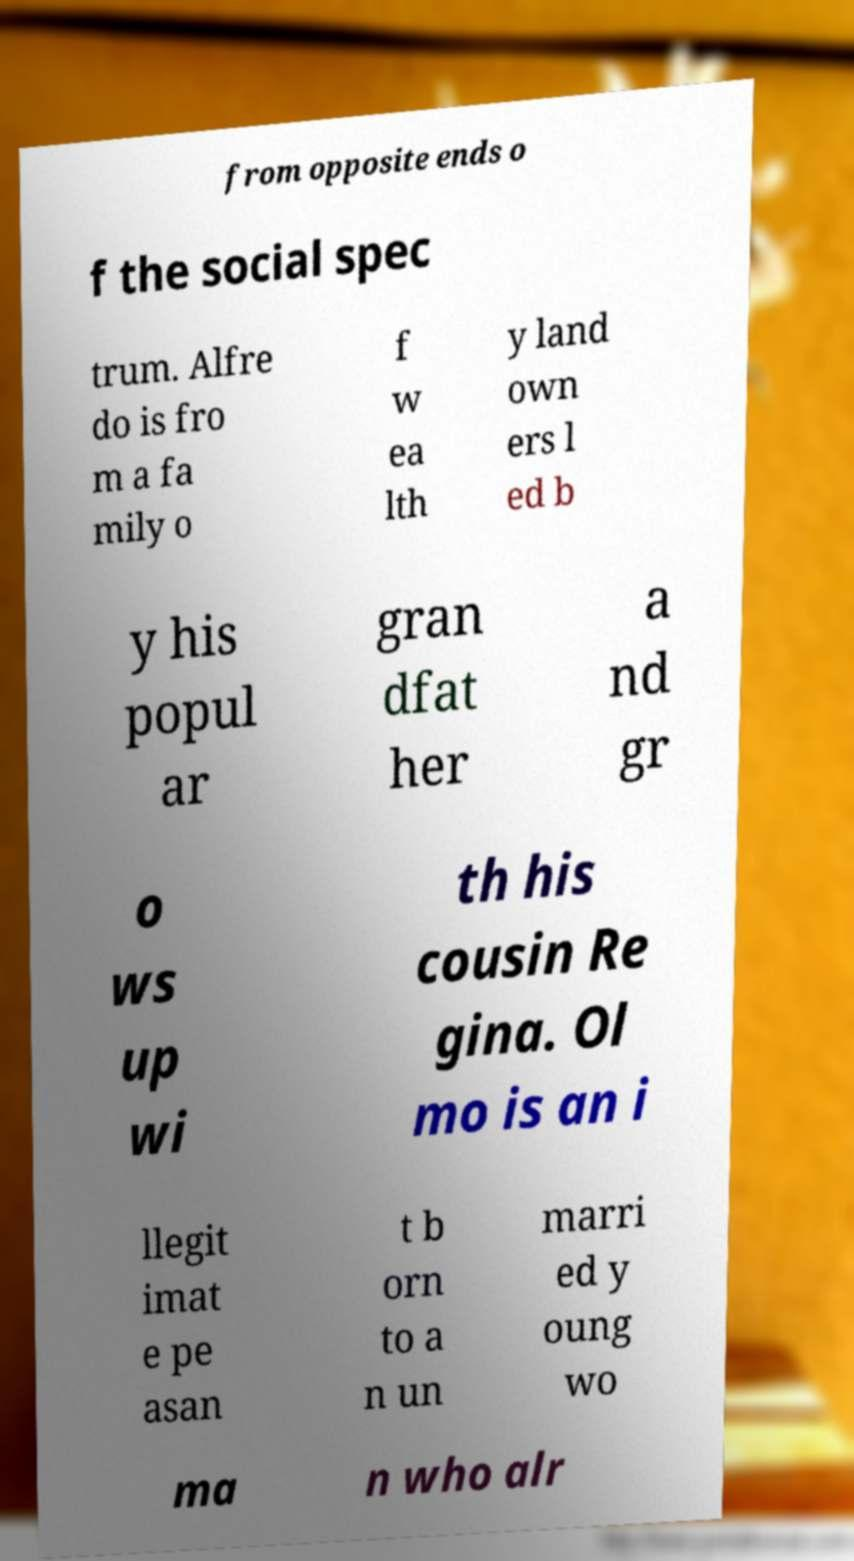Please read and relay the text visible in this image. What does it say? from opposite ends o f the social spec trum. Alfre do is fro m a fa mily o f w ea lth y land own ers l ed b y his popul ar gran dfat her a nd gr o ws up wi th his cousin Re gina. Ol mo is an i llegit imat e pe asan t b orn to a n un marri ed y oung wo ma n who alr 